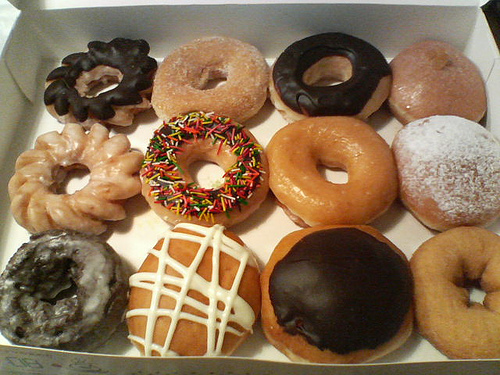What flavors can you identify from the doughnuts in the image? From the image, I can discern a variety of flavors such as chocolate frosted, vanilla glazed, strawberry with sprinkles, plain sugar dusted, and a classic chocolate glazed doughnut, among others. 